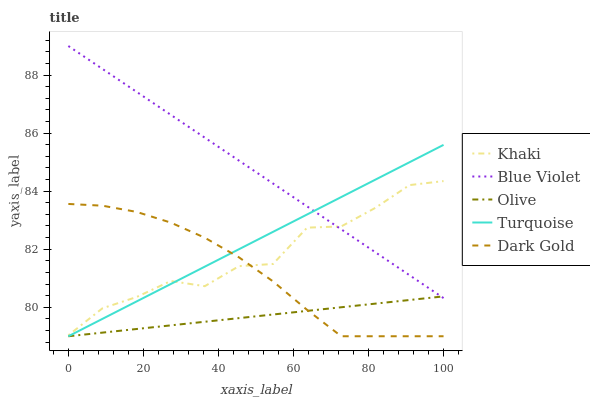Does Olive have the minimum area under the curve?
Answer yes or no. Yes. Does Blue Violet have the maximum area under the curve?
Answer yes or no. Yes. Does Turquoise have the minimum area under the curve?
Answer yes or no. No. Does Turquoise have the maximum area under the curve?
Answer yes or no. No. Is Turquoise the smoothest?
Answer yes or no. Yes. Is Khaki the roughest?
Answer yes or no. Yes. Is Khaki the smoothest?
Answer yes or no. No. Is Turquoise the roughest?
Answer yes or no. No. Does Olive have the lowest value?
Answer yes or no. Yes. Does Khaki have the lowest value?
Answer yes or no. No. Does Blue Violet have the highest value?
Answer yes or no. Yes. Does Turquoise have the highest value?
Answer yes or no. No. Is Olive less than Khaki?
Answer yes or no. Yes. Is Khaki greater than Olive?
Answer yes or no. Yes. Does Dark Gold intersect Khaki?
Answer yes or no. Yes. Is Dark Gold less than Khaki?
Answer yes or no. No. Is Dark Gold greater than Khaki?
Answer yes or no. No. Does Olive intersect Khaki?
Answer yes or no. No. 